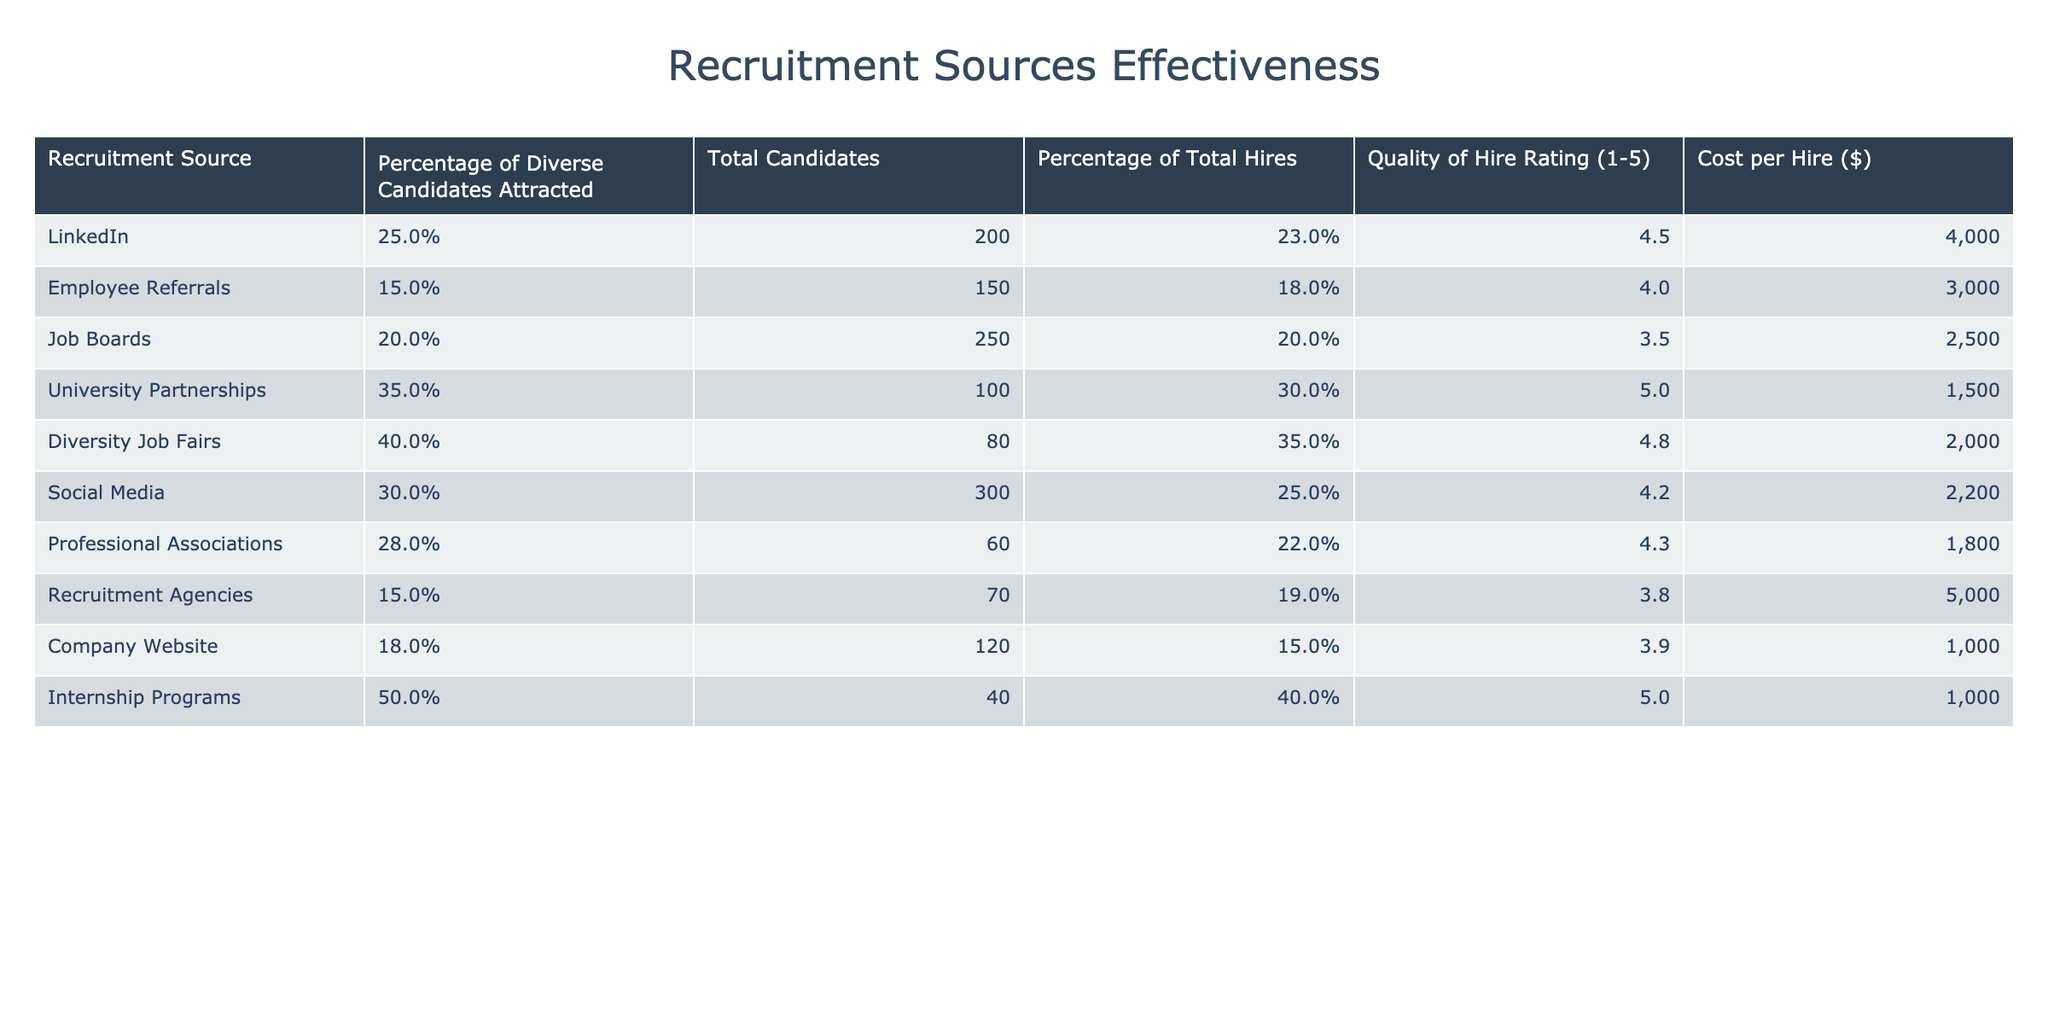What is the highest percentage of diverse candidates attracted among the listed recruitment sources? The table shows the "Percentage of Diverse Candidates Attracted" for each source. The maximum value is 50% from Internship Programs.
Answer: 50% What is the total number of candidates attracted through University Partnerships? The table specifies that 100 candidates were attracted through University Partnerships.
Answer: 100 Which recruitment source has the highest Quality of Hire Rating? By comparing the "Quality of Hire Rating", we see that both University Partnerships and Internship Programs have a rating of 5.0, which is the highest.
Answer: University Partnerships and Internship Programs What is the average cost per hire across all recruitment sources? To find the average cost per hire, sum all costs ($4000 + $3000 + $2500 + $1500 + $2000 + $2200 + $1800 + $5000 + $1000 + $1000 = $22500) and divide by the number of sources (10), which equals $2250.
Answer: $2250 Is the percentage of total hires from Diversity Job Fairs greater than the average percentage of total hires from all sources? Calculate the average percentage of total hires (23% + 18% + 20% + 30% + 35% + 25% + 22% + 19% + 15% + 40% =  22.7%). The percentage from Diversity Job Fairs is 35%, which is greater than 22.7%.
Answer: Yes Which recruitment source has the lowest cost per hire? The table shows that the lowest cost per hire is from both Internship Programs and Company Website, which are both $1000.
Answer: Internship Programs and Company Website What is the percentage difference in the quality of hire rating between the highest and lowest-rated sources? The highest rating is 5.0 (University Partnerships and Internship Programs) and the lowest is 3.5 (Job Boards). The difference is 5.0 - 3.5 = 1.5.
Answer: 1.5 How many more diverse candidates were attracted through Diversity Job Fairs compared to Employee Referrals? Diversity Job Fairs attracted 40 candidates, while Employee Referrals attracted 15. The difference is 40 - 15 = 25.
Answer: 25 Which recruitment sources have a Quality of Hire Rating higher than 4.0? The sources with a rating higher than 4.0 are: LinkedIn (4.5), University Partnerships (5.0), Diversity Job Fairs (4.8), Social Media (4.2), Professional Associations (4.3), and Internship Programs (5.0).
Answer: LinkedIn, University Partnerships, Diversity Job Fairs, Social Media, Professional Associations, and Internship Programs What is the total percentage of diverse candidates attracted from all sources combined? The table lists specific percentages for each source, but they can't be simply summed together as each represents a different total. We cannot provide a valid total percentage without knowing how to aggregate the data.
Answer: Cannot be determined Which recruitment source provides the best combination of high percentage of diverse candidates attracted and the lowest cost per hire? A comparison of sources with a high percentage (such as Diversity Job Fairs at 40% and $2000 per hire) and lower costs shows Diversity Job Fairs as effective.
Answer: Diversity Job Fairs 